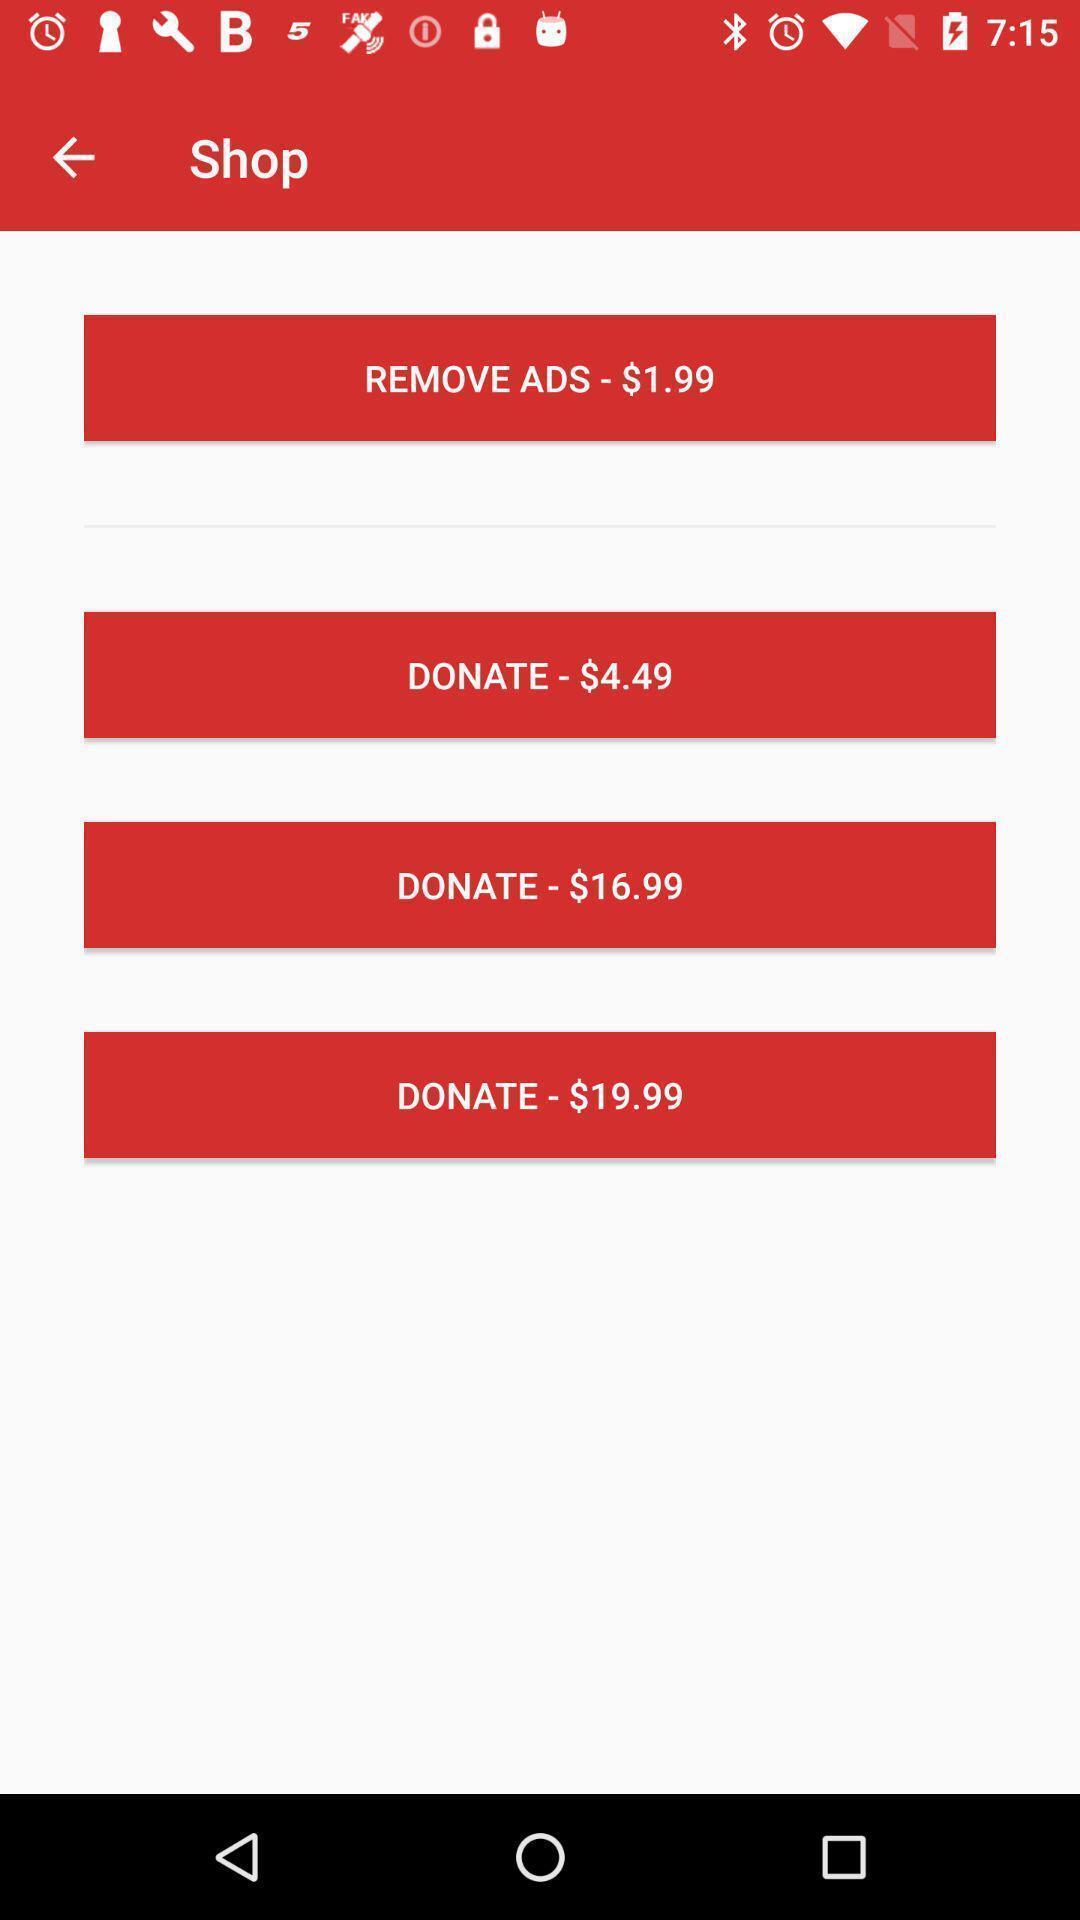Describe the content in this image. To remove ads pay in dollars of shop app. 